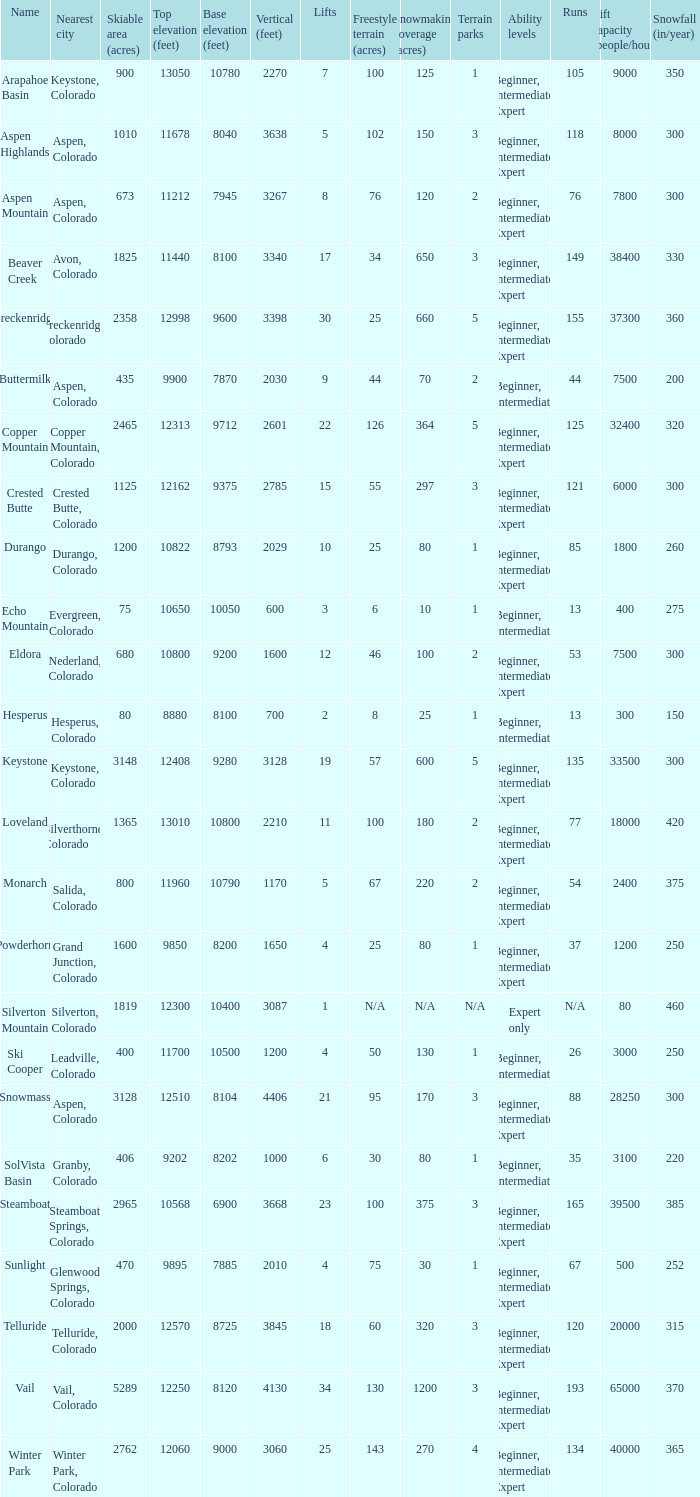If the name is Steamboat, what is the top elevation? 10568.0. 